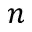Convert formula to latex. <formula><loc_0><loc_0><loc_500><loc_500>n</formula> 